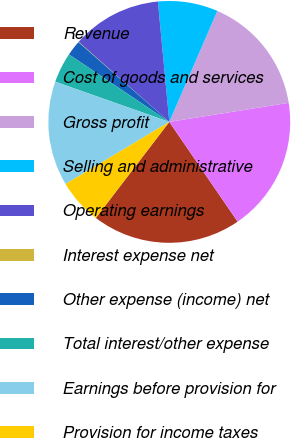<chart> <loc_0><loc_0><loc_500><loc_500><pie_chart><fcel>Revenue<fcel>Cost of goods and services<fcel>Gross profit<fcel>Selling and administrative<fcel>Operating earnings<fcel>Interest expense net<fcel>Other expense (income) net<fcel>Total interest/other expense<fcel>Earnings before provision for<fcel>Provision for income taxes<nl><fcel>19.95%<fcel>17.96%<fcel>15.97%<fcel>8.01%<fcel>11.99%<fcel>0.05%<fcel>2.04%<fcel>4.03%<fcel>13.98%<fcel>6.02%<nl></chart> 